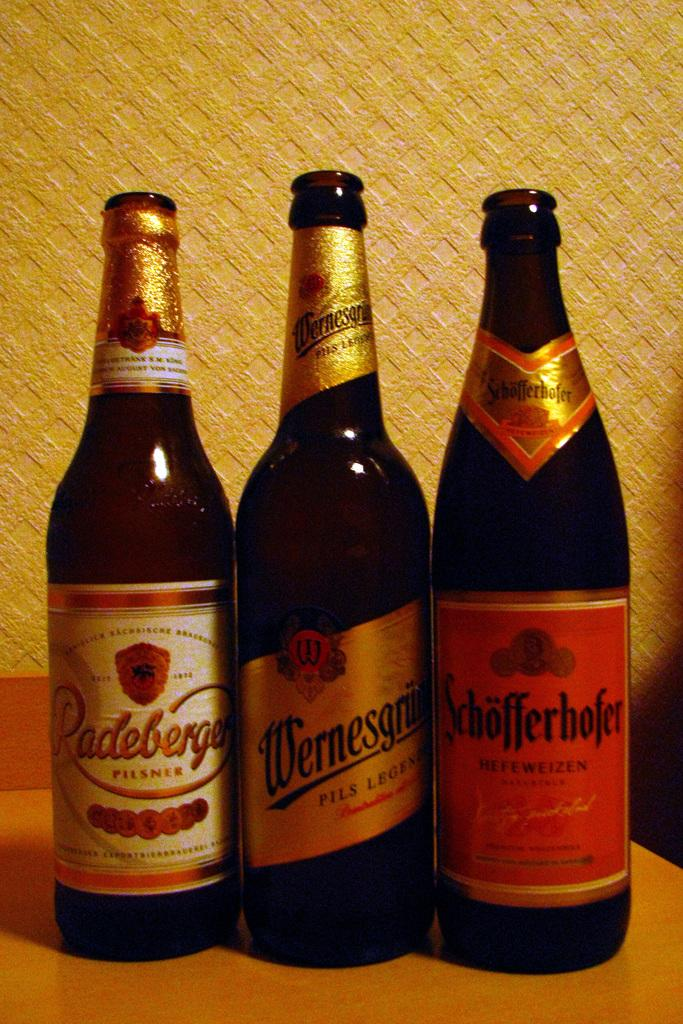Provide a one-sentence caption for the provided image. Three opened dark bottles, including a bottle of Pilsner, sit on a table. 